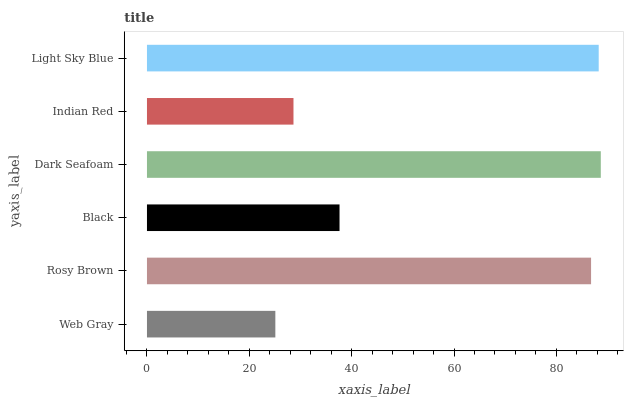Is Web Gray the minimum?
Answer yes or no. Yes. Is Dark Seafoam the maximum?
Answer yes or no. Yes. Is Rosy Brown the minimum?
Answer yes or no. No. Is Rosy Brown the maximum?
Answer yes or no. No. Is Rosy Brown greater than Web Gray?
Answer yes or no. Yes. Is Web Gray less than Rosy Brown?
Answer yes or no. Yes. Is Web Gray greater than Rosy Brown?
Answer yes or no. No. Is Rosy Brown less than Web Gray?
Answer yes or no. No. Is Rosy Brown the high median?
Answer yes or no. Yes. Is Black the low median?
Answer yes or no. Yes. Is Light Sky Blue the high median?
Answer yes or no. No. Is Dark Seafoam the low median?
Answer yes or no. No. 